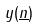Convert formula to latex. <formula><loc_0><loc_0><loc_500><loc_500>y ( \underline { n } )</formula> 